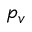<formula> <loc_0><loc_0><loc_500><loc_500>p _ { v }</formula> 